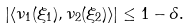<formula> <loc_0><loc_0><loc_500><loc_500>\left | \langle \nu _ { 1 } ( \xi _ { 1 } ) , \nu _ { 2 } ( \xi _ { 2 } ) \rangle \right | \leq 1 - \delta .</formula> 